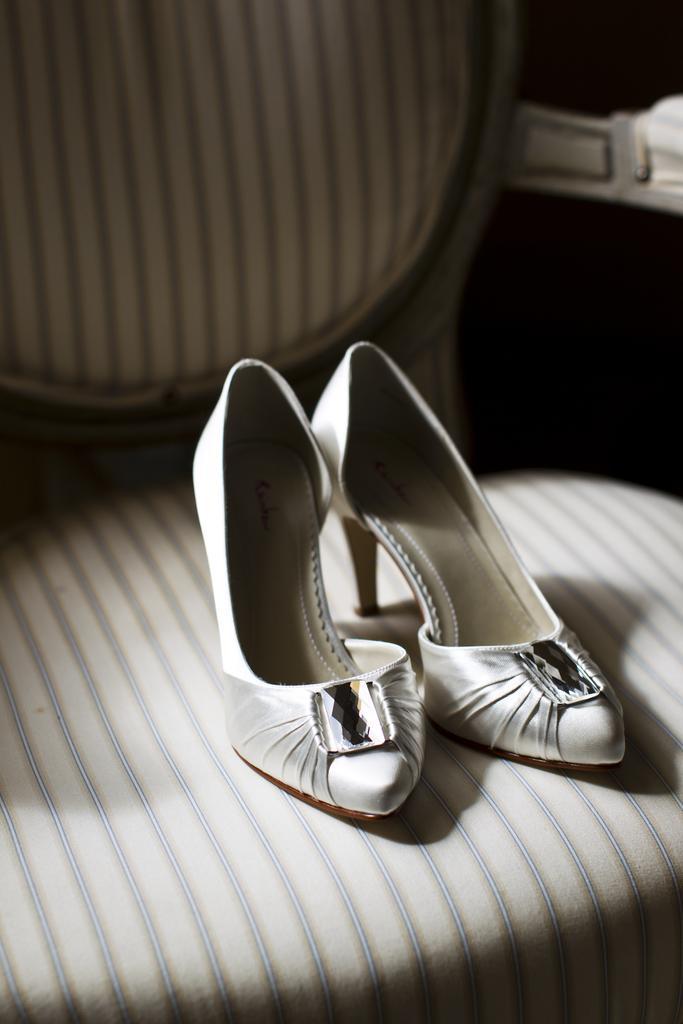In one or two sentences, can you explain what this image depicts? In this picture there is a pair of shoes in the center of the image, on a chair. 